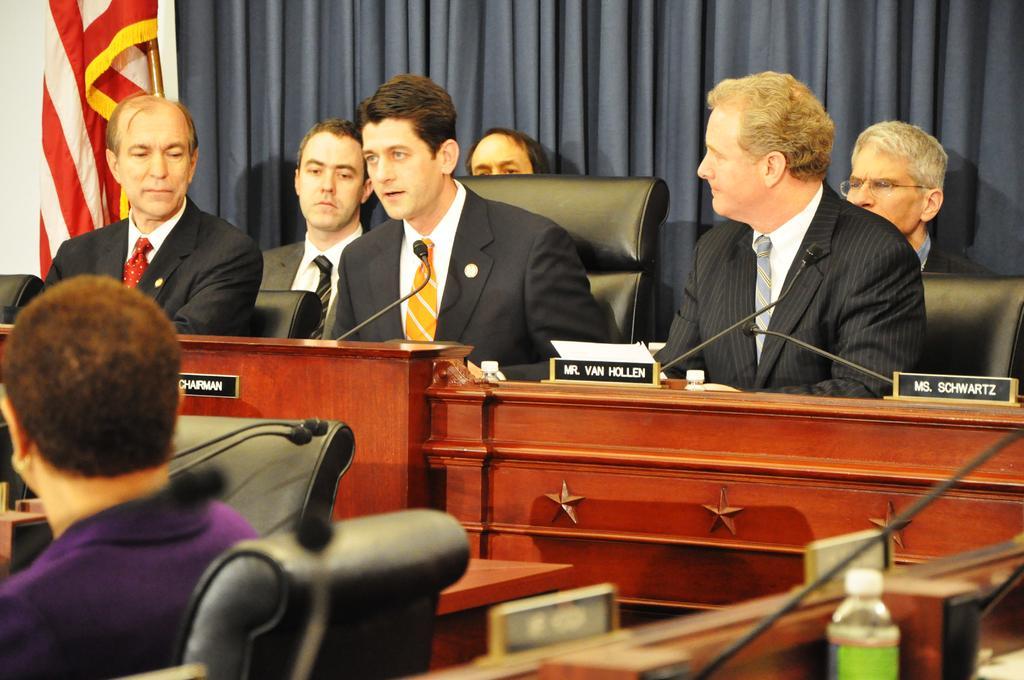In one or two sentences, can you explain what this image depicts? In this image we can see a few people sitting on the chairs, in front them, there are tables, on the tables, we can see a few name boards, water bottles, and mics, in the background we can see a curtain and a flag. 